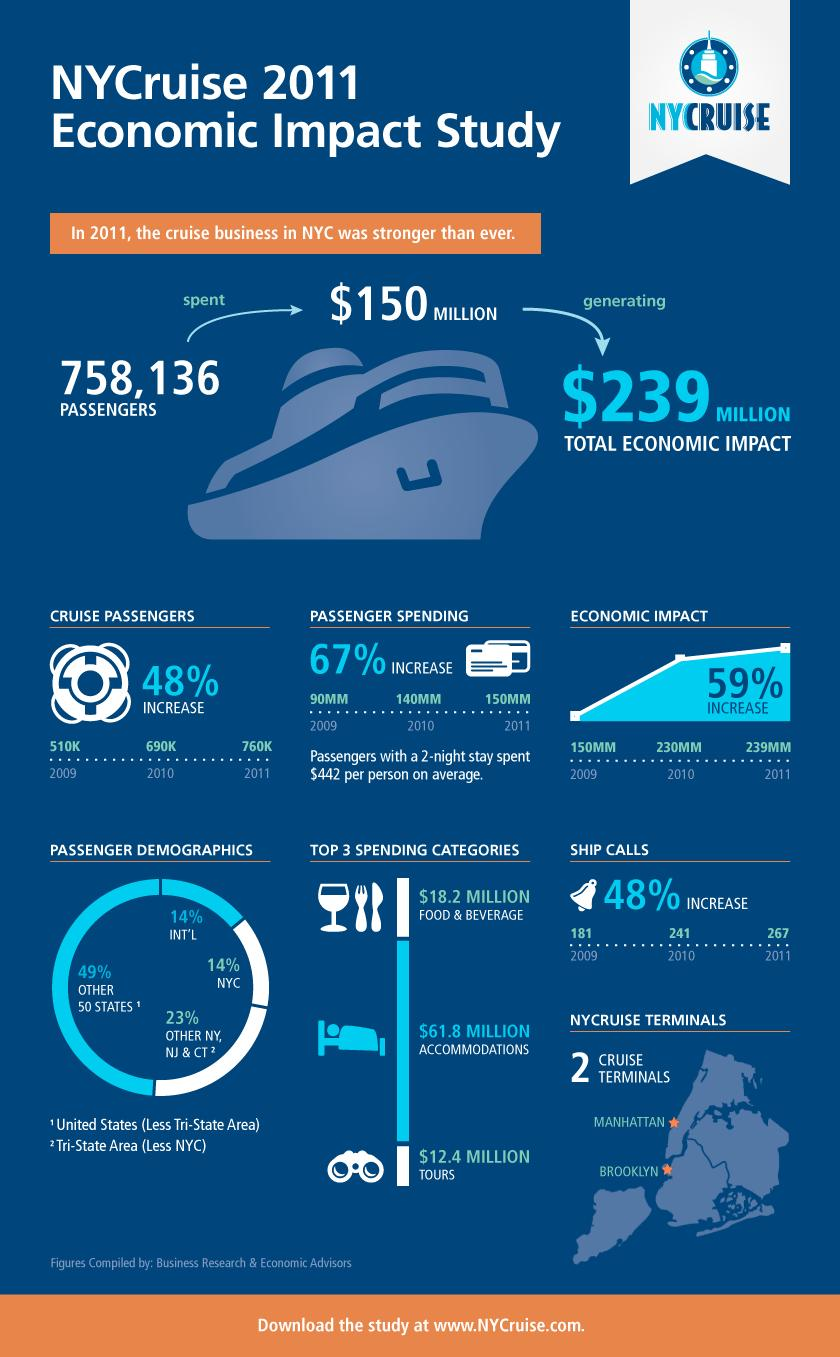Outline some significant characteristics in this image. In 2010, the cruise industry generated an economic impact of approximately 230 million dollars for New York City. In 2010, a total of 690,000 cruise passengers visited New York City. In 2009, an estimated 510,000 cruise passengers traveled to New York City. The number of ship calls in the cruise industry in New York City increased by 48% in 2011. In 2010, a total of 241 ship calls were made in the cruise industry of New York City. 